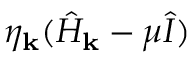Convert formula to latex. <formula><loc_0><loc_0><loc_500><loc_500>\eta _ { k } ( \hat { H } _ { k } - \mu \hat { I } )</formula> 